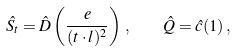Convert formula to latex. <formula><loc_0><loc_0><loc_500><loc_500>\hat { S _ { t } } = \hat { D } \left ( \frac { e } { ( t \cdot l ) ^ { 2 } } \right ) \, , \quad \hat { Q } = \hat { c } ( 1 ) \, ,</formula> 